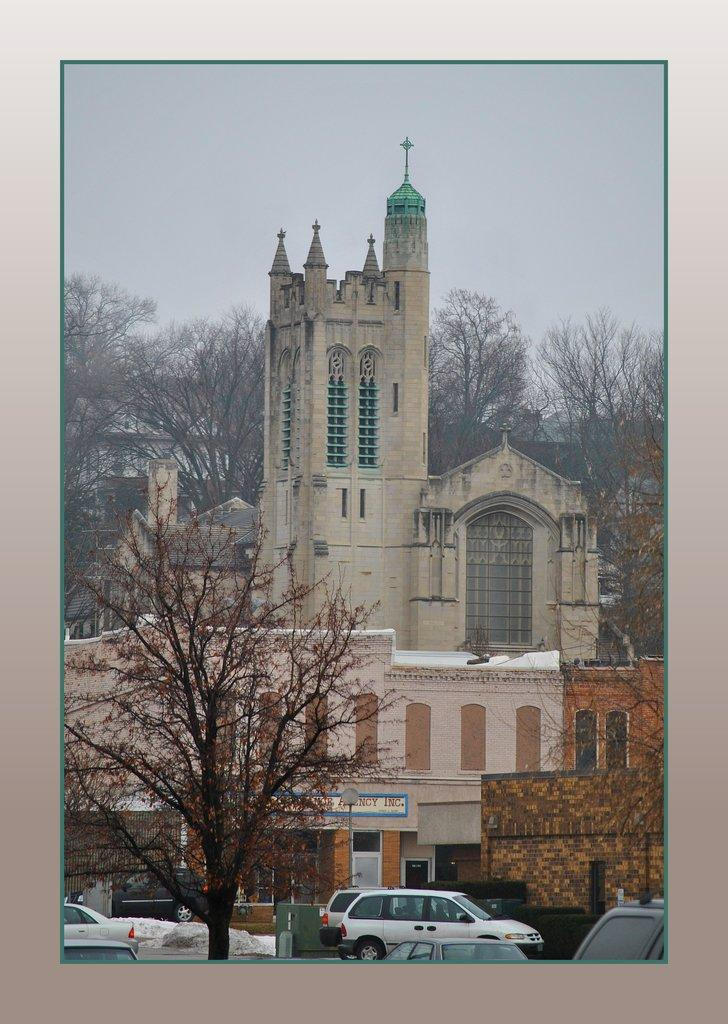What type of vehicles can be seen in the image? There are cars in the image. What other objects or features can be seen in the image? There are trees and buildings in the image. Who is the manager of the meeting taking place in the image? There is no meeting or manager present in the image. How many horses can be seen in the image? There are no horses present in the image. 